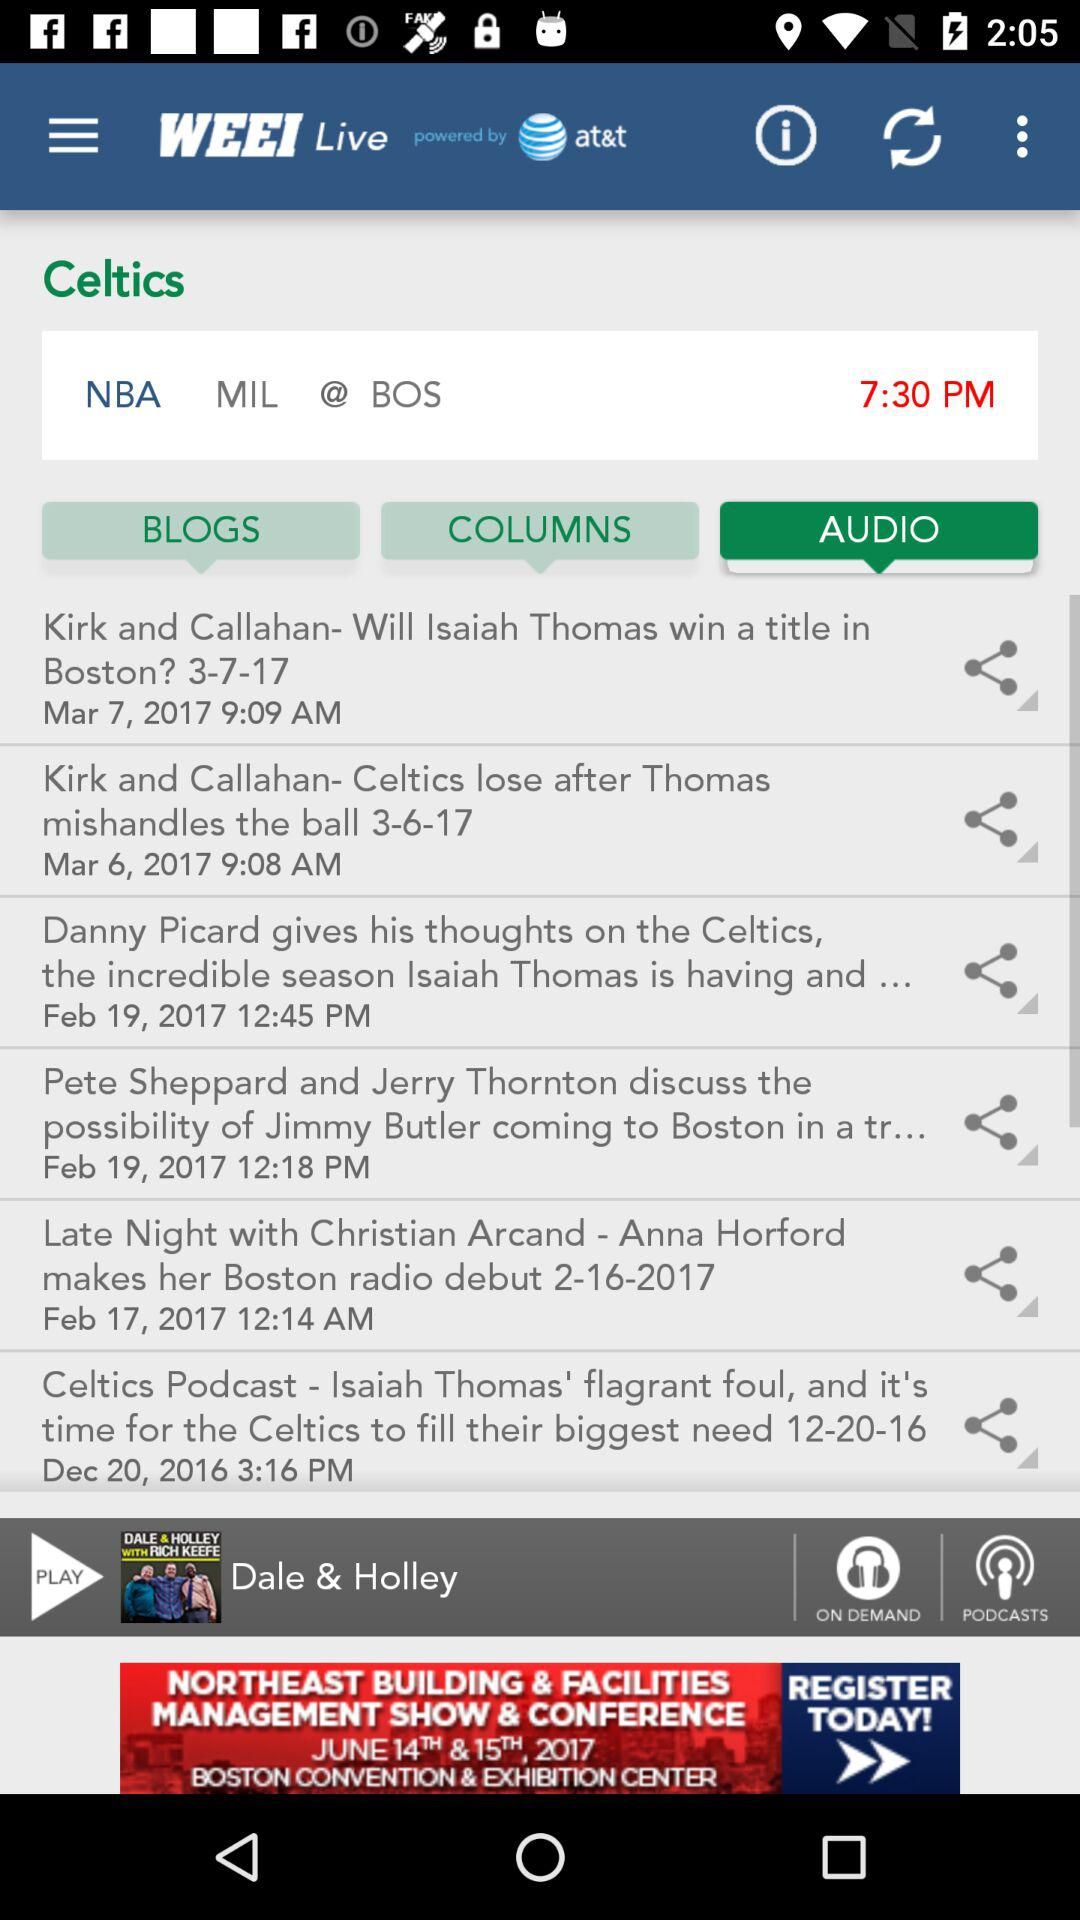Which song is selected to play? The song that has been selected to play is Dale & Holley. 